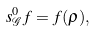Convert formula to latex. <formula><loc_0><loc_0><loc_500><loc_500>s ^ { 0 } _ { \mathcal { G } } f = f ( \rho ) ,</formula> 